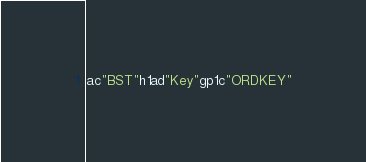<code> <loc_0><loc_0><loc_500><loc_500><_SML_>ac"BST"h1ad"Key"gp1c"ORDKEY"</code> 